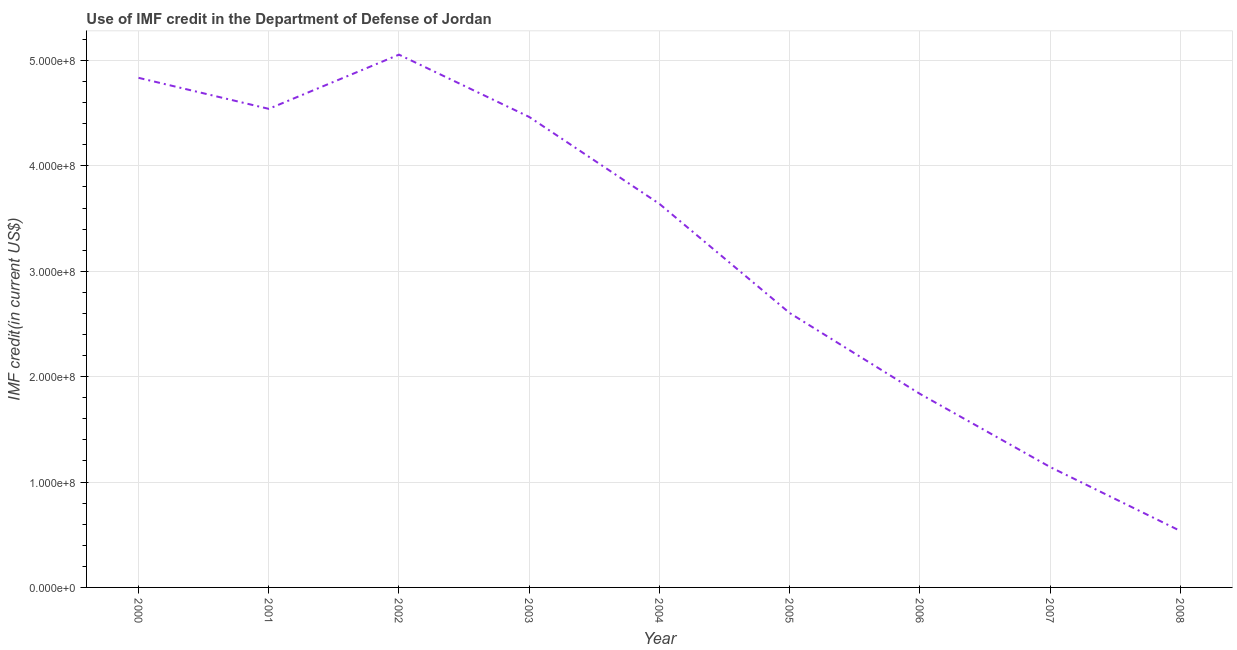What is the use of imf credit in dod in 2002?
Provide a short and direct response. 5.06e+08. Across all years, what is the maximum use of imf credit in dod?
Your response must be concise. 5.06e+08. Across all years, what is the minimum use of imf credit in dod?
Keep it short and to the point. 5.36e+07. In which year was the use of imf credit in dod minimum?
Keep it short and to the point. 2008. What is the sum of the use of imf credit in dod?
Your answer should be very brief. 2.87e+09. What is the difference between the use of imf credit in dod in 2002 and 2003?
Ensure brevity in your answer.  5.91e+07. What is the average use of imf credit in dod per year?
Your answer should be compact. 3.18e+08. What is the median use of imf credit in dod?
Keep it short and to the point. 3.64e+08. Do a majority of the years between 2006 and 2003 (inclusive) have use of imf credit in dod greater than 200000000 US$?
Your answer should be very brief. Yes. What is the ratio of the use of imf credit in dod in 2001 to that in 2008?
Give a very brief answer. 8.48. What is the difference between the highest and the second highest use of imf credit in dod?
Give a very brief answer. 2.20e+07. What is the difference between the highest and the lowest use of imf credit in dod?
Make the answer very short. 4.52e+08. How many lines are there?
Make the answer very short. 1. Are the values on the major ticks of Y-axis written in scientific E-notation?
Offer a terse response. Yes. Does the graph contain grids?
Your response must be concise. Yes. What is the title of the graph?
Make the answer very short. Use of IMF credit in the Department of Defense of Jordan. What is the label or title of the X-axis?
Your answer should be very brief. Year. What is the label or title of the Y-axis?
Ensure brevity in your answer.  IMF credit(in current US$). What is the IMF credit(in current US$) in 2000?
Give a very brief answer. 4.84e+08. What is the IMF credit(in current US$) of 2001?
Keep it short and to the point. 4.54e+08. What is the IMF credit(in current US$) of 2002?
Keep it short and to the point. 5.06e+08. What is the IMF credit(in current US$) in 2003?
Your response must be concise. 4.46e+08. What is the IMF credit(in current US$) in 2004?
Your response must be concise. 3.64e+08. What is the IMF credit(in current US$) in 2005?
Provide a short and direct response. 2.60e+08. What is the IMF credit(in current US$) of 2006?
Your response must be concise. 1.84e+08. What is the IMF credit(in current US$) of 2007?
Ensure brevity in your answer.  1.14e+08. What is the IMF credit(in current US$) in 2008?
Provide a succinct answer. 5.36e+07. What is the difference between the IMF credit(in current US$) in 2000 and 2001?
Provide a succinct answer. 2.94e+07. What is the difference between the IMF credit(in current US$) in 2000 and 2002?
Offer a very short reply. -2.20e+07. What is the difference between the IMF credit(in current US$) in 2000 and 2003?
Your answer should be compact. 3.71e+07. What is the difference between the IMF credit(in current US$) in 2000 and 2004?
Ensure brevity in your answer.  1.20e+08. What is the difference between the IMF credit(in current US$) in 2000 and 2005?
Offer a very short reply. 2.23e+08. What is the difference between the IMF credit(in current US$) in 2000 and 2006?
Offer a terse response. 3.00e+08. What is the difference between the IMF credit(in current US$) in 2000 and 2007?
Ensure brevity in your answer.  3.69e+08. What is the difference between the IMF credit(in current US$) in 2000 and 2008?
Provide a succinct answer. 4.30e+08. What is the difference between the IMF credit(in current US$) in 2001 and 2002?
Make the answer very short. -5.14e+07. What is the difference between the IMF credit(in current US$) in 2001 and 2003?
Offer a terse response. 7.70e+06. What is the difference between the IMF credit(in current US$) in 2001 and 2004?
Give a very brief answer. 9.02e+07. What is the difference between the IMF credit(in current US$) in 2001 and 2005?
Your answer should be very brief. 1.94e+08. What is the difference between the IMF credit(in current US$) in 2001 and 2006?
Your response must be concise. 2.70e+08. What is the difference between the IMF credit(in current US$) in 2001 and 2007?
Offer a terse response. 3.40e+08. What is the difference between the IMF credit(in current US$) in 2001 and 2008?
Give a very brief answer. 4.01e+08. What is the difference between the IMF credit(in current US$) in 2002 and 2003?
Ensure brevity in your answer.  5.91e+07. What is the difference between the IMF credit(in current US$) in 2002 and 2004?
Offer a terse response. 1.42e+08. What is the difference between the IMF credit(in current US$) in 2002 and 2005?
Your answer should be very brief. 2.45e+08. What is the difference between the IMF credit(in current US$) in 2002 and 2006?
Provide a succinct answer. 3.22e+08. What is the difference between the IMF credit(in current US$) in 2002 and 2007?
Make the answer very short. 3.91e+08. What is the difference between the IMF credit(in current US$) in 2002 and 2008?
Keep it short and to the point. 4.52e+08. What is the difference between the IMF credit(in current US$) in 2003 and 2004?
Make the answer very short. 8.25e+07. What is the difference between the IMF credit(in current US$) in 2003 and 2005?
Give a very brief answer. 1.86e+08. What is the difference between the IMF credit(in current US$) in 2003 and 2006?
Keep it short and to the point. 2.63e+08. What is the difference between the IMF credit(in current US$) in 2003 and 2007?
Your answer should be compact. 3.32e+08. What is the difference between the IMF credit(in current US$) in 2003 and 2008?
Your answer should be compact. 3.93e+08. What is the difference between the IMF credit(in current US$) in 2004 and 2005?
Provide a succinct answer. 1.04e+08. What is the difference between the IMF credit(in current US$) in 2004 and 2006?
Provide a short and direct response. 1.80e+08. What is the difference between the IMF credit(in current US$) in 2004 and 2007?
Offer a terse response. 2.50e+08. What is the difference between the IMF credit(in current US$) in 2004 and 2008?
Provide a succinct answer. 3.10e+08. What is the difference between the IMF credit(in current US$) in 2005 and 2006?
Offer a terse response. 7.67e+07. What is the difference between the IMF credit(in current US$) in 2005 and 2007?
Offer a very short reply. 1.46e+08. What is the difference between the IMF credit(in current US$) in 2005 and 2008?
Provide a succinct answer. 2.07e+08. What is the difference between the IMF credit(in current US$) in 2006 and 2007?
Keep it short and to the point. 6.94e+07. What is the difference between the IMF credit(in current US$) in 2006 and 2008?
Give a very brief answer. 1.30e+08. What is the difference between the IMF credit(in current US$) in 2007 and 2008?
Provide a succinct answer. 6.07e+07. What is the ratio of the IMF credit(in current US$) in 2000 to that in 2001?
Your answer should be compact. 1.06. What is the ratio of the IMF credit(in current US$) in 2000 to that in 2002?
Offer a terse response. 0.96. What is the ratio of the IMF credit(in current US$) in 2000 to that in 2003?
Offer a terse response. 1.08. What is the ratio of the IMF credit(in current US$) in 2000 to that in 2004?
Your answer should be very brief. 1.33. What is the ratio of the IMF credit(in current US$) in 2000 to that in 2005?
Offer a terse response. 1.86. What is the ratio of the IMF credit(in current US$) in 2000 to that in 2006?
Your response must be concise. 2.63. What is the ratio of the IMF credit(in current US$) in 2000 to that in 2007?
Your answer should be very brief. 4.23. What is the ratio of the IMF credit(in current US$) in 2000 to that in 2008?
Keep it short and to the point. 9.03. What is the ratio of the IMF credit(in current US$) in 2001 to that in 2002?
Offer a very short reply. 0.9. What is the ratio of the IMF credit(in current US$) in 2001 to that in 2003?
Keep it short and to the point. 1.02. What is the ratio of the IMF credit(in current US$) in 2001 to that in 2004?
Offer a terse response. 1.25. What is the ratio of the IMF credit(in current US$) in 2001 to that in 2005?
Offer a very short reply. 1.74. What is the ratio of the IMF credit(in current US$) in 2001 to that in 2006?
Your response must be concise. 2.47. What is the ratio of the IMF credit(in current US$) in 2001 to that in 2007?
Offer a very short reply. 3.98. What is the ratio of the IMF credit(in current US$) in 2001 to that in 2008?
Your answer should be very brief. 8.48. What is the ratio of the IMF credit(in current US$) in 2002 to that in 2003?
Ensure brevity in your answer.  1.13. What is the ratio of the IMF credit(in current US$) in 2002 to that in 2004?
Make the answer very short. 1.39. What is the ratio of the IMF credit(in current US$) in 2002 to that in 2005?
Your answer should be compact. 1.94. What is the ratio of the IMF credit(in current US$) in 2002 to that in 2006?
Provide a succinct answer. 2.75. What is the ratio of the IMF credit(in current US$) in 2002 to that in 2007?
Your answer should be very brief. 4.42. What is the ratio of the IMF credit(in current US$) in 2002 to that in 2008?
Keep it short and to the point. 9.44. What is the ratio of the IMF credit(in current US$) in 2003 to that in 2004?
Provide a succinct answer. 1.23. What is the ratio of the IMF credit(in current US$) in 2003 to that in 2005?
Give a very brief answer. 1.72. What is the ratio of the IMF credit(in current US$) in 2003 to that in 2006?
Provide a short and direct response. 2.43. What is the ratio of the IMF credit(in current US$) in 2003 to that in 2007?
Ensure brevity in your answer.  3.91. What is the ratio of the IMF credit(in current US$) in 2003 to that in 2008?
Offer a very short reply. 8.34. What is the ratio of the IMF credit(in current US$) in 2004 to that in 2005?
Ensure brevity in your answer.  1.4. What is the ratio of the IMF credit(in current US$) in 2004 to that in 2006?
Provide a short and direct response. 1.98. What is the ratio of the IMF credit(in current US$) in 2004 to that in 2007?
Give a very brief answer. 3.19. What is the ratio of the IMF credit(in current US$) in 2004 to that in 2008?
Offer a terse response. 6.79. What is the ratio of the IMF credit(in current US$) in 2005 to that in 2006?
Keep it short and to the point. 1.42. What is the ratio of the IMF credit(in current US$) in 2005 to that in 2007?
Your answer should be compact. 2.28. What is the ratio of the IMF credit(in current US$) in 2005 to that in 2008?
Your answer should be very brief. 4.86. What is the ratio of the IMF credit(in current US$) in 2006 to that in 2007?
Your answer should be very brief. 1.61. What is the ratio of the IMF credit(in current US$) in 2006 to that in 2008?
Give a very brief answer. 3.43. What is the ratio of the IMF credit(in current US$) in 2007 to that in 2008?
Ensure brevity in your answer.  2.13. 